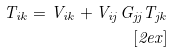Convert formula to latex. <formula><loc_0><loc_0><loc_500><loc_500>T _ { i k } = V _ { i k } + V _ { i j } G _ { j j } T _ { j k } \\ [ 2 e x ]</formula> 